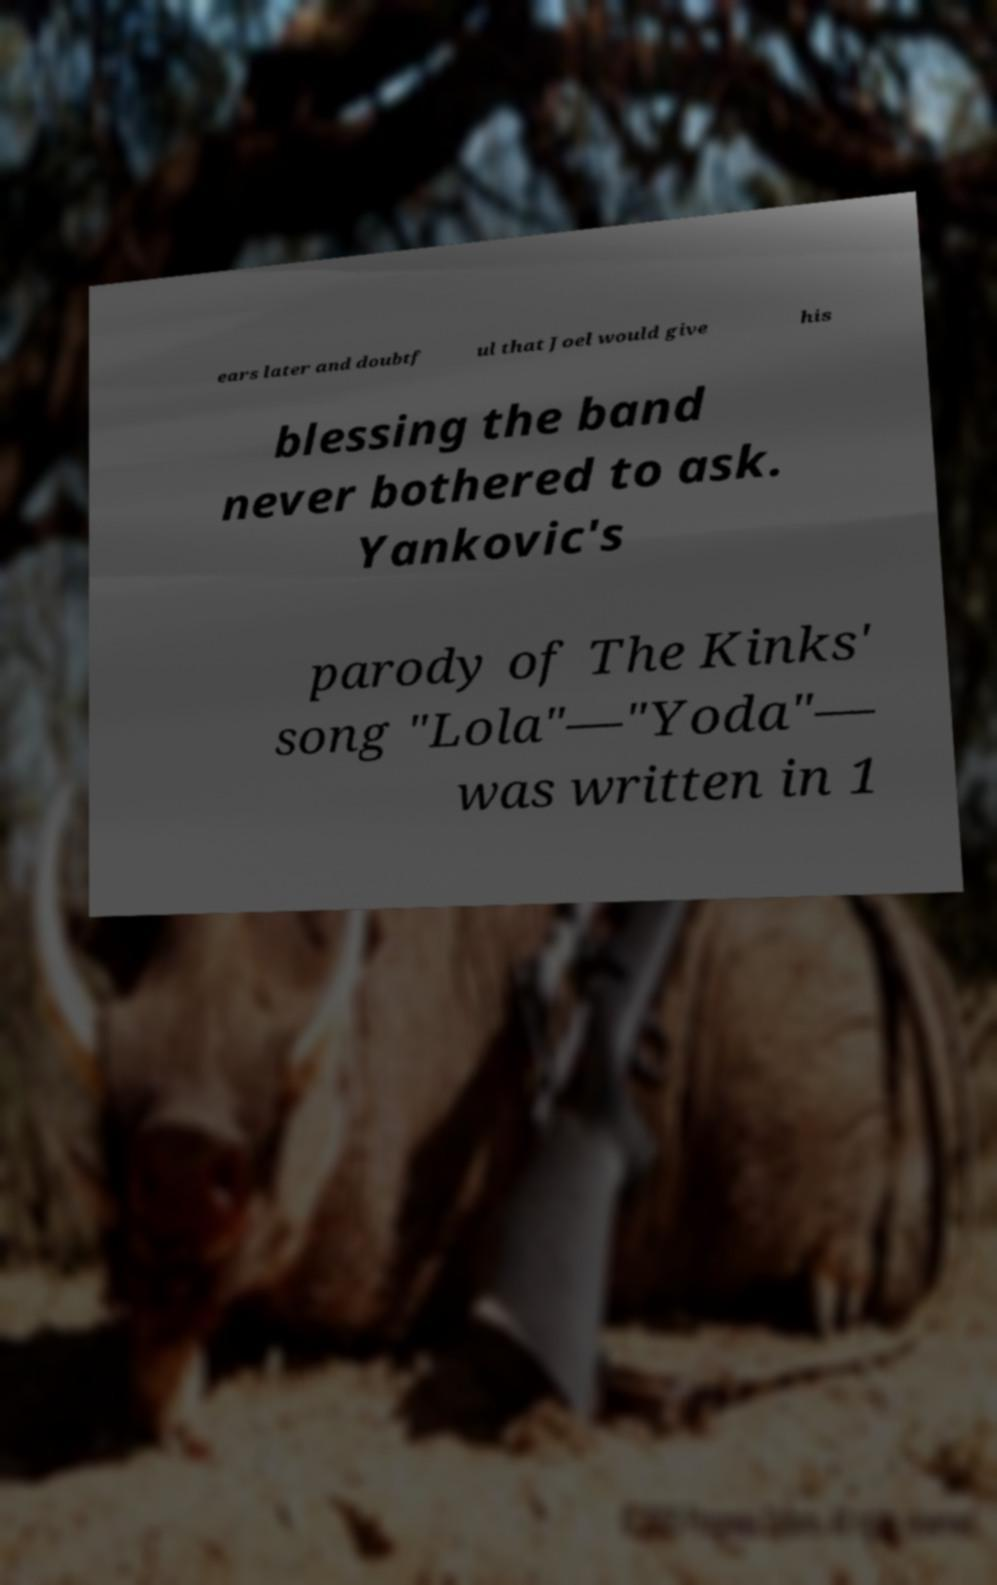Can you read and provide the text displayed in the image?This photo seems to have some interesting text. Can you extract and type it out for me? ears later and doubtf ul that Joel would give his blessing the band never bothered to ask. Yankovic's parody of The Kinks' song "Lola"—"Yoda"— was written in 1 